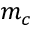Convert formula to latex. <formula><loc_0><loc_0><loc_500><loc_500>m _ { c }</formula> 